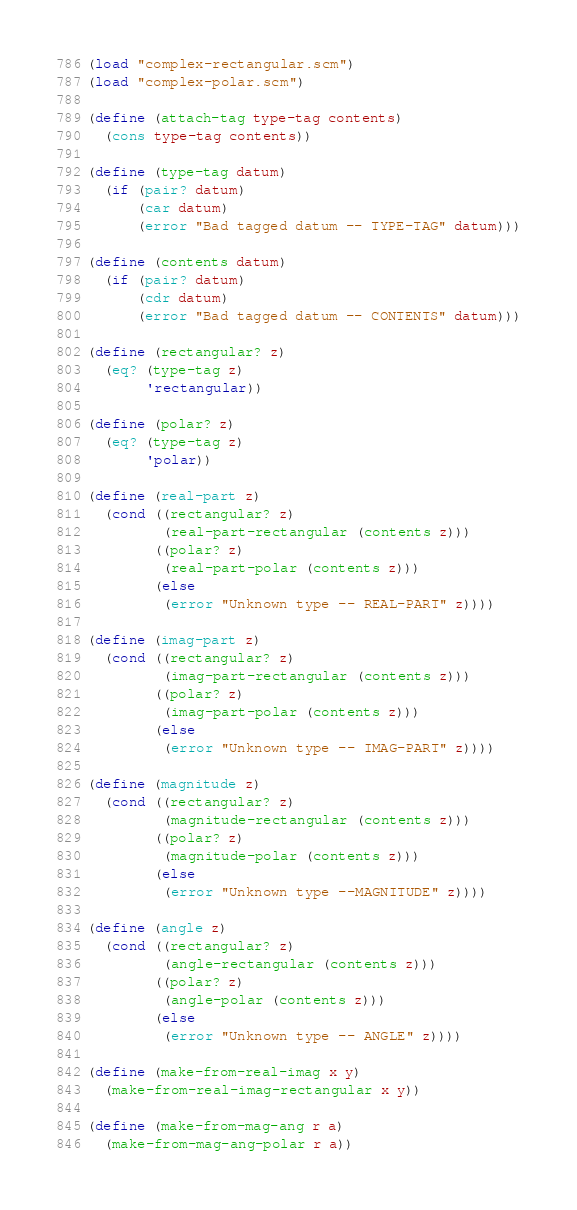Convert code to text. <code><loc_0><loc_0><loc_500><loc_500><_Scheme_>(load "complex-rectangular.scm")
(load "complex-polar.scm")

(define (attach-tag type-tag contents)
  (cons type-tag contents))

(define (type-tag datum)
  (if (pair? datum)
      (car datum)
      (error "Bad tagged datum -- TYPE-TAG" datum)))

(define (contents datum)
  (if (pair? datum)
      (cdr datum)
      (error "Bad tagged datum -- CONTENTS" datum)))

(define (rectangular? z)
  (eq? (type-tag z)
       'rectangular))

(define (polar? z)
  (eq? (type-tag z)
       'polar))

(define (real-part z)
  (cond ((rectangular? z)
         (real-part-rectangular (contents z)))
        ((polar? z)
         (real-part-polar (contents z)))
        (else
         (error "Unknown type -- REAL-PART" z))))

(define (imag-part z)
  (cond ((rectangular? z)
         (imag-part-rectangular (contents z)))
        ((polar? z)
         (imag-part-polar (contents z)))
        (else
         (error "Unknown type -- IMAG-PART" z))))

(define (magnitude z)
  (cond ((rectangular? z)
         (magnitude-rectangular (contents z)))
        ((polar? z)
         (magnitude-polar (contents z)))
        (else
         (error "Unknown type --MAGNITUDE" z))))

(define (angle z)
  (cond ((rectangular? z)
         (angle-rectangular (contents z)))
        ((polar? z)
         (angle-polar (contents z)))
        (else
         (error "Unknown type -- ANGLE" z))))

(define (make-from-real-imag x y)
  (make-from-real-imag-rectangular x y))

(define (make-from-mag-ang r a)
  (make-from-mag-ang-polar r a))</code> 